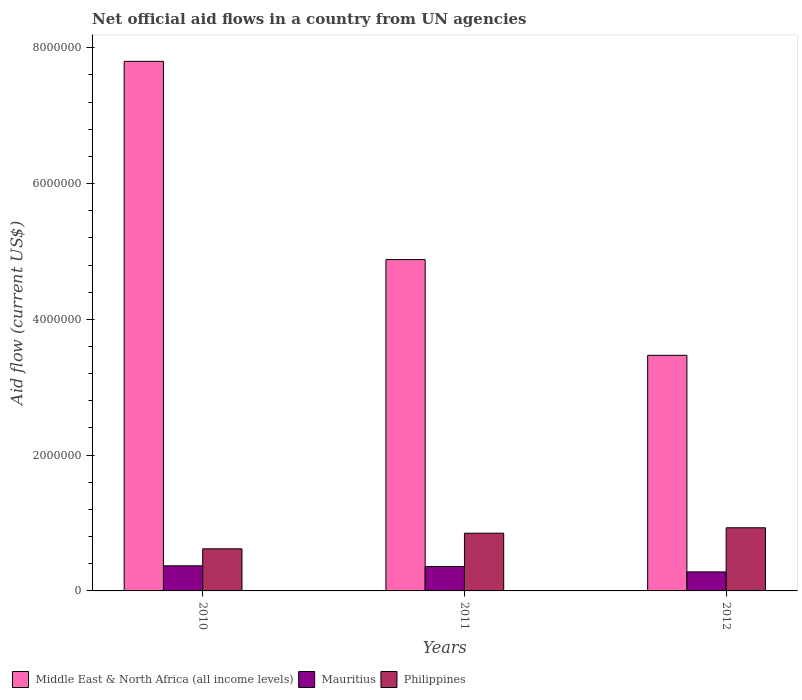How many different coloured bars are there?
Your answer should be compact. 3. How many groups of bars are there?
Offer a very short reply. 3. Are the number of bars per tick equal to the number of legend labels?
Offer a very short reply. Yes. Are the number of bars on each tick of the X-axis equal?
Provide a short and direct response. Yes. How many bars are there on the 3rd tick from the left?
Offer a very short reply. 3. In how many cases, is the number of bars for a given year not equal to the number of legend labels?
Your answer should be very brief. 0. What is the net official aid flow in Mauritius in 2010?
Keep it short and to the point. 3.70e+05. Across all years, what is the maximum net official aid flow in Philippines?
Offer a very short reply. 9.30e+05. Across all years, what is the minimum net official aid flow in Philippines?
Offer a very short reply. 6.20e+05. In which year was the net official aid flow in Middle East & North Africa (all income levels) maximum?
Offer a terse response. 2010. In which year was the net official aid flow in Philippines minimum?
Provide a short and direct response. 2010. What is the total net official aid flow in Philippines in the graph?
Your answer should be very brief. 2.40e+06. What is the difference between the net official aid flow in Philippines in 2010 and that in 2012?
Give a very brief answer. -3.10e+05. What is the difference between the net official aid flow in Middle East & North Africa (all income levels) in 2011 and the net official aid flow in Philippines in 2010?
Provide a short and direct response. 4.26e+06. What is the average net official aid flow in Philippines per year?
Offer a terse response. 8.00e+05. In the year 2011, what is the difference between the net official aid flow in Middle East & North Africa (all income levels) and net official aid flow in Mauritius?
Your answer should be compact. 4.52e+06. What is the ratio of the net official aid flow in Middle East & North Africa (all income levels) in 2011 to that in 2012?
Offer a very short reply. 1.41. Is the net official aid flow in Philippines in 2010 less than that in 2012?
Offer a terse response. Yes. Is the difference between the net official aid flow in Middle East & North Africa (all income levels) in 2011 and 2012 greater than the difference between the net official aid flow in Mauritius in 2011 and 2012?
Provide a succinct answer. Yes. What is the difference between the highest and the lowest net official aid flow in Middle East & North Africa (all income levels)?
Make the answer very short. 4.33e+06. In how many years, is the net official aid flow in Middle East & North Africa (all income levels) greater than the average net official aid flow in Middle East & North Africa (all income levels) taken over all years?
Your answer should be compact. 1. What does the 2nd bar from the left in 2012 represents?
Keep it short and to the point. Mauritius. Is it the case that in every year, the sum of the net official aid flow in Middle East & North Africa (all income levels) and net official aid flow in Philippines is greater than the net official aid flow in Mauritius?
Make the answer very short. Yes. How many bars are there?
Your response must be concise. 9. Are all the bars in the graph horizontal?
Your answer should be very brief. No. How many years are there in the graph?
Your response must be concise. 3. Are the values on the major ticks of Y-axis written in scientific E-notation?
Your answer should be very brief. No. Does the graph contain grids?
Provide a short and direct response. No. Where does the legend appear in the graph?
Your answer should be compact. Bottom left. How many legend labels are there?
Offer a very short reply. 3. What is the title of the graph?
Keep it short and to the point. Net official aid flows in a country from UN agencies. Does "Small states" appear as one of the legend labels in the graph?
Your answer should be compact. No. What is the label or title of the Y-axis?
Provide a succinct answer. Aid flow (current US$). What is the Aid flow (current US$) of Middle East & North Africa (all income levels) in 2010?
Your answer should be very brief. 7.80e+06. What is the Aid flow (current US$) of Mauritius in 2010?
Your answer should be compact. 3.70e+05. What is the Aid flow (current US$) in Philippines in 2010?
Your response must be concise. 6.20e+05. What is the Aid flow (current US$) in Middle East & North Africa (all income levels) in 2011?
Your answer should be very brief. 4.88e+06. What is the Aid flow (current US$) in Philippines in 2011?
Your response must be concise. 8.50e+05. What is the Aid flow (current US$) of Middle East & North Africa (all income levels) in 2012?
Your response must be concise. 3.47e+06. What is the Aid flow (current US$) in Philippines in 2012?
Your answer should be very brief. 9.30e+05. Across all years, what is the maximum Aid flow (current US$) in Middle East & North Africa (all income levels)?
Give a very brief answer. 7.80e+06. Across all years, what is the maximum Aid flow (current US$) of Philippines?
Give a very brief answer. 9.30e+05. Across all years, what is the minimum Aid flow (current US$) of Middle East & North Africa (all income levels)?
Provide a succinct answer. 3.47e+06. Across all years, what is the minimum Aid flow (current US$) of Philippines?
Your answer should be compact. 6.20e+05. What is the total Aid flow (current US$) of Middle East & North Africa (all income levels) in the graph?
Keep it short and to the point. 1.62e+07. What is the total Aid flow (current US$) of Mauritius in the graph?
Your response must be concise. 1.01e+06. What is the total Aid flow (current US$) in Philippines in the graph?
Offer a very short reply. 2.40e+06. What is the difference between the Aid flow (current US$) of Middle East & North Africa (all income levels) in 2010 and that in 2011?
Make the answer very short. 2.92e+06. What is the difference between the Aid flow (current US$) in Mauritius in 2010 and that in 2011?
Provide a succinct answer. 10000. What is the difference between the Aid flow (current US$) of Philippines in 2010 and that in 2011?
Provide a short and direct response. -2.30e+05. What is the difference between the Aid flow (current US$) of Middle East & North Africa (all income levels) in 2010 and that in 2012?
Your answer should be compact. 4.33e+06. What is the difference between the Aid flow (current US$) in Mauritius in 2010 and that in 2012?
Give a very brief answer. 9.00e+04. What is the difference between the Aid flow (current US$) in Philippines in 2010 and that in 2012?
Your answer should be very brief. -3.10e+05. What is the difference between the Aid flow (current US$) in Middle East & North Africa (all income levels) in 2011 and that in 2012?
Your response must be concise. 1.41e+06. What is the difference between the Aid flow (current US$) in Mauritius in 2011 and that in 2012?
Your answer should be very brief. 8.00e+04. What is the difference between the Aid flow (current US$) of Middle East & North Africa (all income levels) in 2010 and the Aid flow (current US$) of Mauritius in 2011?
Make the answer very short. 7.44e+06. What is the difference between the Aid flow (current US$) in Middle East & North Africa (all income levels) in 2010 and the Aid flow (current US$) in Philippines in 2011?
Ensure brevity in your answer.  6.95e+06. What is the difference between the Aid flow (current US$) of Mauritius in 2010 and the Aid flow (current US$) of Philippines in 2011?
Your response must be concise. -4.80e+05. What is the difference between the Aid flow (current US$) of Middle East & North Africa (all income levels) in 2010 and the Aid flow (current US$) of Mauritius in 2012?
Offer a very short reply. 7.52e+06. What is the difference between the Aid flow (current US$) of Middle East & North Africa (all income levels) in 2010 and the Aid flow (current US$) of Philippines in 2012?
Your response must be concise. 6.87e+06. What is the difference between the Aid flow (current US$) of Mauritius in 2010 and the Aid flow (current US$) of Philippines in 2012?
Give a very brief answer. -5.60e+05. What is the difference between the Aid flow (current US$) in Middle East & North Africa (all income levels) in 2011 and the Aid flow (current US$) in Mauritius in 2012?
Provide a succinct answer. 4.60e+06. What is the difference between the Aid flow (current US$) in Middle East & North Africa (all income levels) in 2011 and the Aid flow (current US$) in Philippines in 2012?
Keep it short and to the point. 3.95e+06. What is the difference between the Aid flow (current US$) of Mauritius in 2011 and the Aid flow (current US$) of Philippines in 2012?
Offer a terse response. -5.70e+05. What is the average Aid flow (current US$) of Middle East & North Africa (all income levels) per year?
Provide a short and direct response. 5.38e+06. What is the average Aid flow (current US$) in Mauritius per year?
Provide a short and direct response. 3.37e+05. In the year 2010, what is the difference between the Aid flow (current US$) of Middle East & North Africa (all income levels) and Aid flow (current US$) of Mauritius?
Offer a terse response. 7.43e+06. In the year 2010, what is the difference between the Aid flow (current US$) in Middle East & North Africa (all income levels) and Aid flow (current US$) in Philippines?
Keep it short and to the point. 7.18e+06. In the year 2010, what is the difference between the Aid flow (current US$) of Mauritius and Aid flow (current US$) of Philippines?
Offer a terse response. -2.50e+05. In the year 2011, what is the difference between the Aid flow (current US$) in Middle East & North Africa (all income levels) and Aid flow (current US$) in Mauritius?
Offer a very short reply. 4.52e+06. In the year 2011, what is the difference between the Aid flow (current US$) in Middle East & North Africa (all income levels) and Aid flow (current US$) in Philippines?
Your answer should be very brief. 4.03e+06. In the year 2011, what is the difference between the Aid flow (current US$) in Mauritius and Aid flow (current US$) in Philippines?
Your answer should be compact. -4.90e+05. In the year 2012, what is the difference between the Aid flow (current US$) in Middle East & North Africa (all income levels) and Aid flow (current US$) in Mauritius?
Make the answer very short. 3.19e+06. In the year 2012, what is the difference between the Aid flow (current US$) of Middle East & North Africa (all income levels) and Aid flow (current US$) of Philippines?
Provide a succinct answer. 2.54e+06. In the year 2012, what is the difference between the Aid flow (current US$) of Mauritius and Aid flow (current US$) of Philippines?
Your response must be concise. -6.50e+05. What is the ratio of the Aid flow (current US$) in Middle East & North Africa (all income levels) in 2010 to that in 2011?
Give a very brief answer. 1.6. What is the ratio of the Aid flow (current US$) in Mauritius in 2010 to that in 2011?
Offer a terse response. 1.03. What is the ratio of the Aid flow (current US$) in Philippines in 2010 to that in 2011?
Your answer should be very brief. 0.73. What is the ratio of the Aid flow (current US$) in Middle East & North Africa (all income levels) in 2010 to that in 2012?
Make the answer very short. 2.25. What is the ratio of the Aid flow (current US$) in Mauritius in 2010 to that in 2012?
Offer a very short reply. 1.32. What is the ratio of the Aid flow (current US$) in Middle East & North Africa (all income levels) in 2011 to that in 2012?
Make the answer very short. 1.41. What is the ratio of the Aid flow (current US$) in Mauritius in 2011 to that in 2012?
Your response must be concise. 1.29. What is the ratio of the Aid flow (current US$) in Philippines in 2011 to that in 2012?
Offer a terse response. 0.91. What is the difference between the highest and the second highest Aid flow (current US$) in Middle East & North Africa (all income levels)?
Keep it short and to the point. 2.92e+06. What is the difference between the highest and the second highest Aid flow (current US$) of Philippines?
Your answer should be compact. 8.00e+04. What is the difference between the highest and the lowest Aid flow (current US$) in Middle East & North Africa (all income levels)?
Keep it short and to the point. 4.33e+06. What is the difference between the highest and the lowest Aid flow (current US$) of Mauritius?
Give a very brief answer. 9.00e+04. 